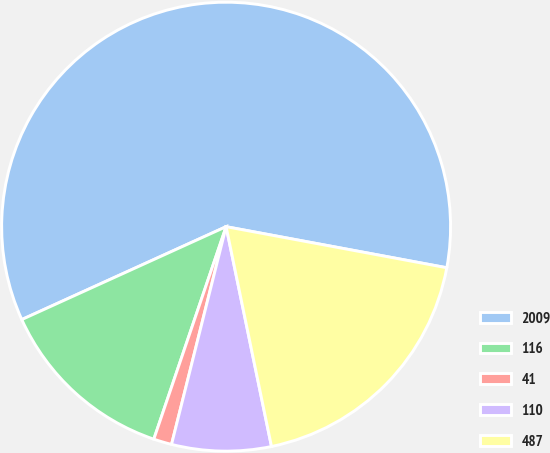Convert chart to OTSL. <chart><loc_0><loc_0><loc_500><loc_500><pie_chart><fcel>2009<fcel>116<fcel>41<fcel>110<fcel>487<nl><fcel>59.72%<fcel>12.99%<fcel>1.31%<fcel>7.15%<fcel>18.83%<nl></chart> 